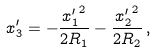<formula> <loc_0><loc_0><loc_500><loc_500>x _ { 3 } ^ { \prime } = - \frac { { x _ { 1 } ^ { \prime } } ^ { 2 } } { 2 R _ { 1 } } - \frac { { x _ { 2 } ^ { \prime } } ^ { 2 } } { 2 R _ { 2 } } \, ,</formula> 